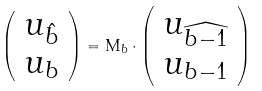<formula> <loc_0><loc_0><loc_500><loc_500>\left ( \begin{array} { c } u _ { \hat { b } } \\ u _ { b } \end{array} \right ) = { \mathsf M } _ { b } \cdot \left ( \begin{array} { c } u _ { \widehat { b - 1 } } \\ u _ { b - 1 } \end{array} \right )</formula> 